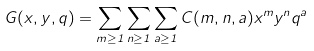Convert formula to latex. <formula><loc_0><loc_0><loc_500><loc_500>G ( x , y , q ) = \sum _ { m \geq 1 } \sum _ { n \geq 1 } \sum _ { a \geq 1 } C ( m , n , a ) x ^ { m } y ^ { n } q ^ { a }</formula> 